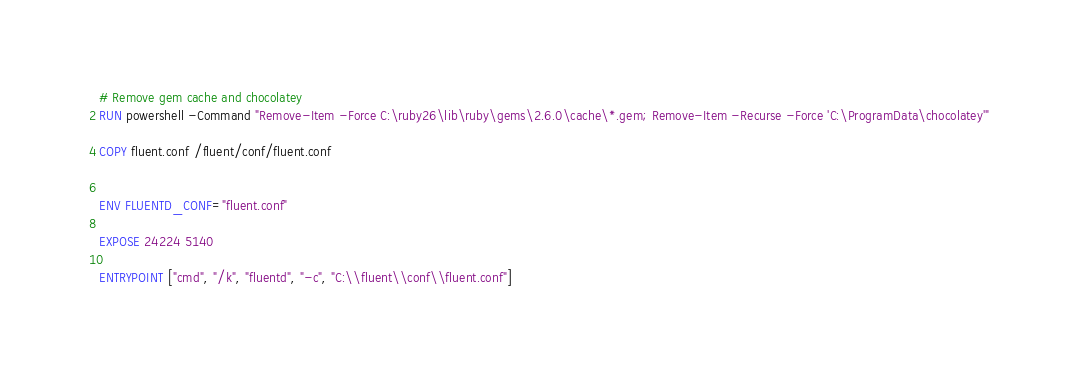Convert code to text. <code><loc_0><loc_0><loc_500><loc_500><_Dockerfile_># Remove gem cache and chocolatey
RUN powershell -Command "Remove-Item -Force C:\ruby26\lib\ruby\gems\2.6.0\cache\*.gem; Remove-Item -Recurse -Force 'C:\ProgramData\chocolatey'"

COPY fluent.conf /fluent/conf/fluent.conf


ENV FLUENTD_CONF="fluent.conf"

EXPOSE 24224 5140

ENTRYPOINT ["cmd", "/k", "fluentd", "-c", "C:\\fluent\\conf\\fluent.conf"]
</code> 